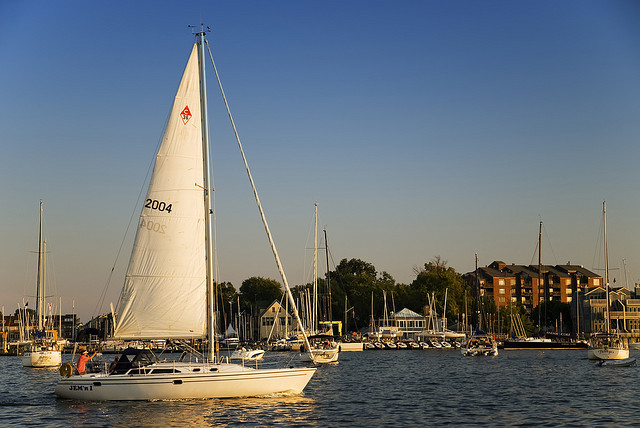Read and extract the text from this image. 2004 